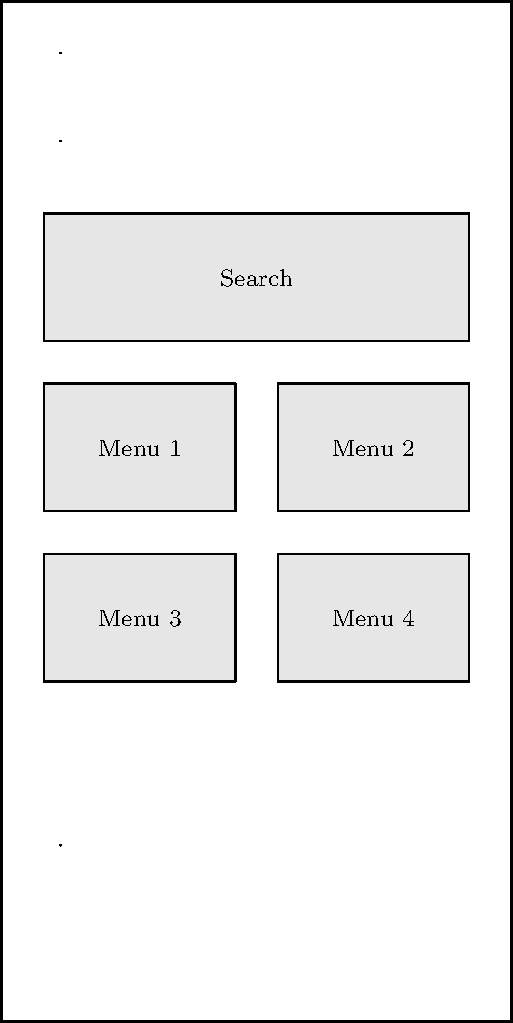Analyze the wireframe sketch of a mobile app interface. Which key principle of mobile UI design is most prominently demonstrated in this layout, and how does it contribute to a better user experience for tech-savvy professionals? 1. Observe the layout: The wireframe shows a clear hierarchy with a search bar at the top, followed by menu items in a grid layout, and a bottom navigation bar.

2. Identify key elements:
   - Search bar prominently placed
   - Menu items in a 2x2 grid
   - Bottom navigation for easy access

3. Recognize the principle: The most prominent principle demonstrated is "Simplicity and Clarity."

4. Analyze how this principle is applied:
   - Clean, uncluttered layout
   - Limited number of menu items (4) for quick decision-making
   - Clear visual separation between elements

5. Consider the user experience for tech-savvy professionals:
   - Easy to navigate and find information quickly
   - Efficient use of screen space
   - Familiar layout pattern common in popular apps

6. Relate to the persona:
   - As a young Brazilian professional at Cisco who loves app-based solutions, this design allows for quick access to key features and efficient task completion.

7. Conclusion: The principle of simplicity and clarity contributes to a better user experience by reducing cognitive load, improving navigation speed, and increasing overall efficiency for tech-savvy users.
Answer: Simplicity and Clarity 